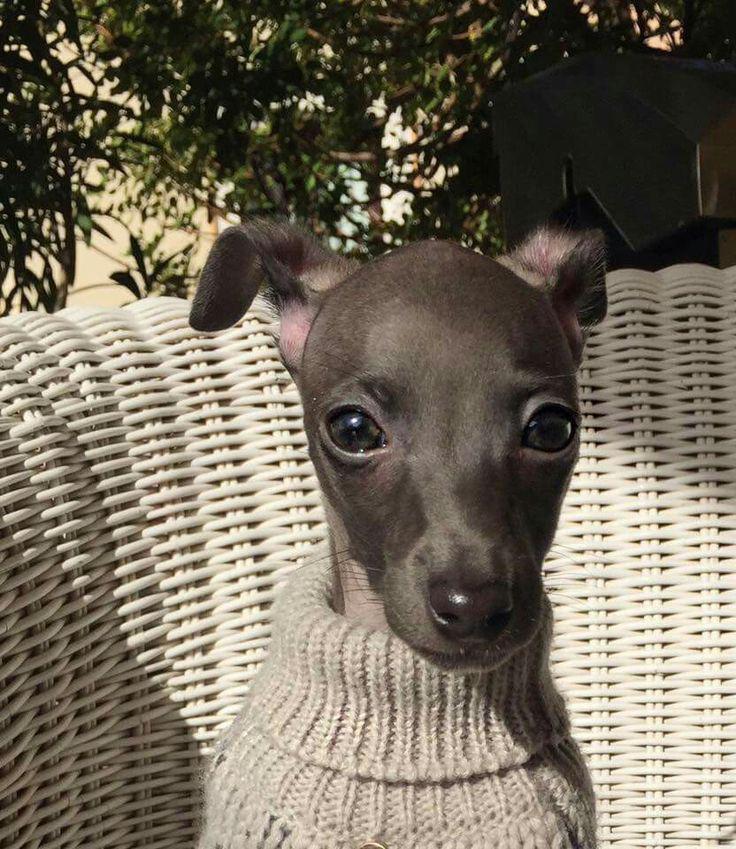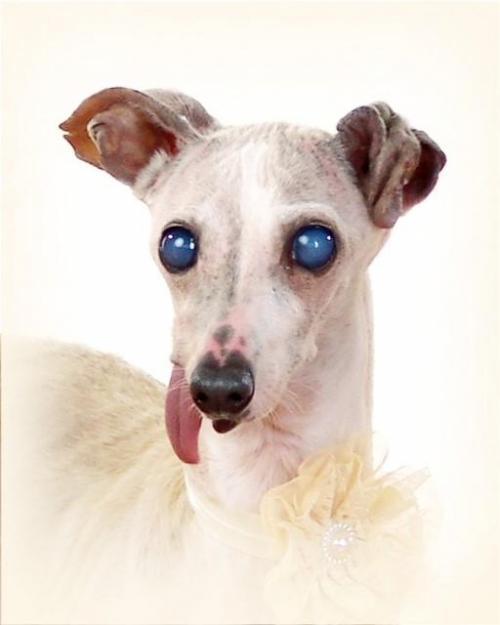The first image is the image on the left, the second image is the image on the right. Given the left and right images, does the statement "Three dogs are posing together in one of the images." hold true? Answer yes or no. No. 